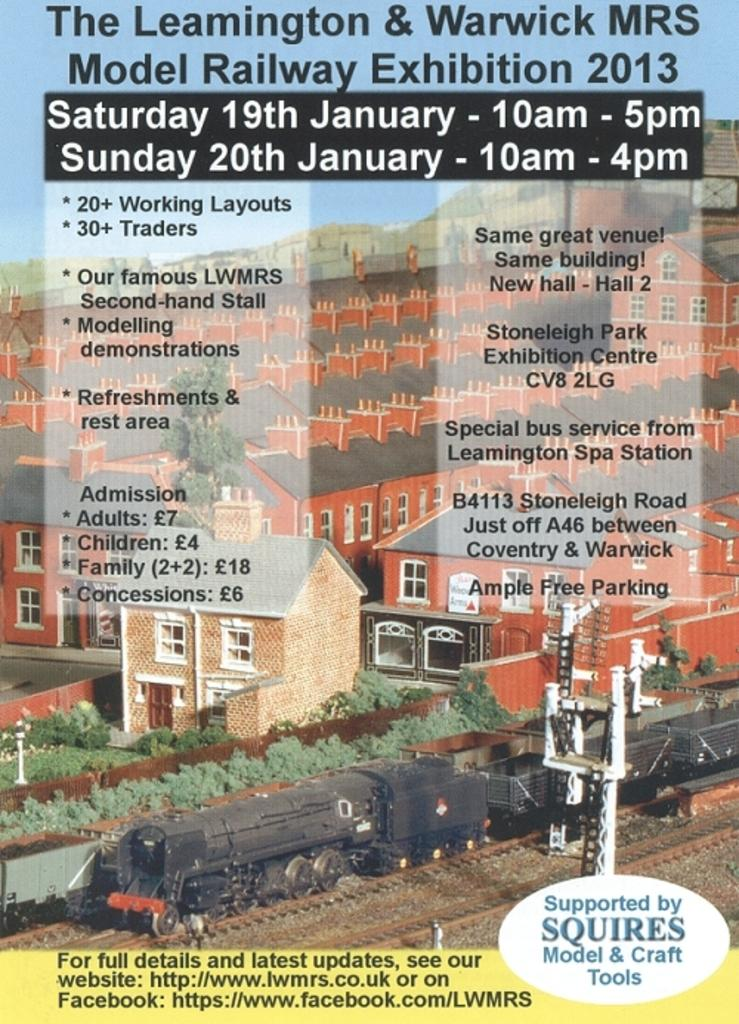<image>
Present a compact description of the photo's key features. A flyer talking about the leamington & Warwick MRS 